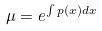Convert formula to latex. <formula><loc_0><loc_0><loc_500><loc_500>\mu = e ^ { \int p ( x ) d x }</formula> 